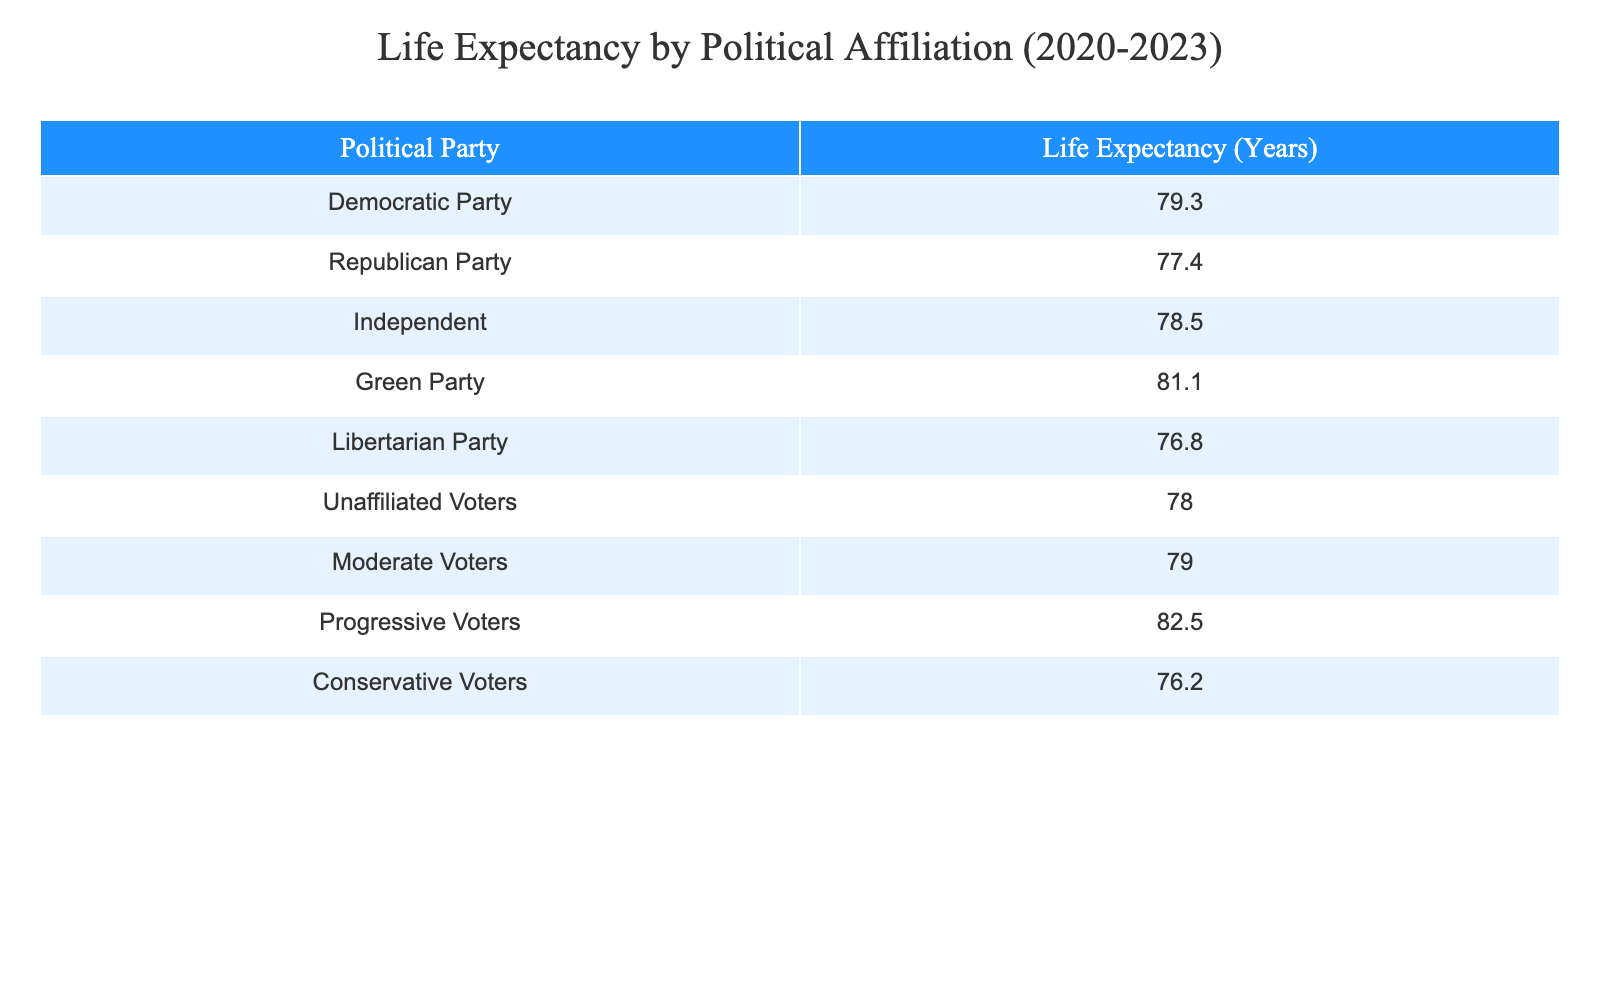What is the life expectancy of Democratic Party members? The table lists the life expectancy for the Democratic Party as 79.3 years.
Answer: 79.3 Which political party has the lowest life expectancy? In the table, the Libertarian Party is listed with a life expectancy of 76.8 years, which is the lowest among the parties presented.
Answer: Libertarian Party What is the average life expectancy of Independent and Unaffiliated voters? The life expectancy for Independent voters is 78.5 years, and for Unaffiliated voters, it is 78.0 years. Adding these values gives 156.5 years. Dividing by 2 gives an average of 78.25 years.
Answer: 78.25 Is the life expectancy for Progressive Voters higher than that of Conservative Voters? The table shows Progressive Voters with a life expectancy of 82.5 years and Conservative Voters with 76.2 years. Since 82.5 is greater than 76.2, the statement is true.
Answer: Yes What is the difference in life expectancy between the Green Party and Conservative Voters? The life expectancy for the Green Party is 81.1 years and for Conservative Voters, it is 76.2 years. Subtracting these gives 81.1 - 76.2 = 4.9 years.
Answer: 4.9 How many political parties have a life expectancy greater than 80 years? Checking the table, the Green Party (81.1) and Progressive Voters (82.5) have life expectancies greater than 80 years. That's a total of 2 parties.
Answer: 2 What is the life expectancy of Moderate Voters? The table states that the life expectancy for Moderate Voters is 79.0 years.
Answer: 79.0 Does the Democratic Party have a higher life expectancy than Unaffiliated Voters? The life expectancy for Democratic Party members is 79.3 years, while for Unaffiliated Voters, it is 78.0 years. Since 79.3 is greater than 78.0, the answer is yes.
Answer: Yes 